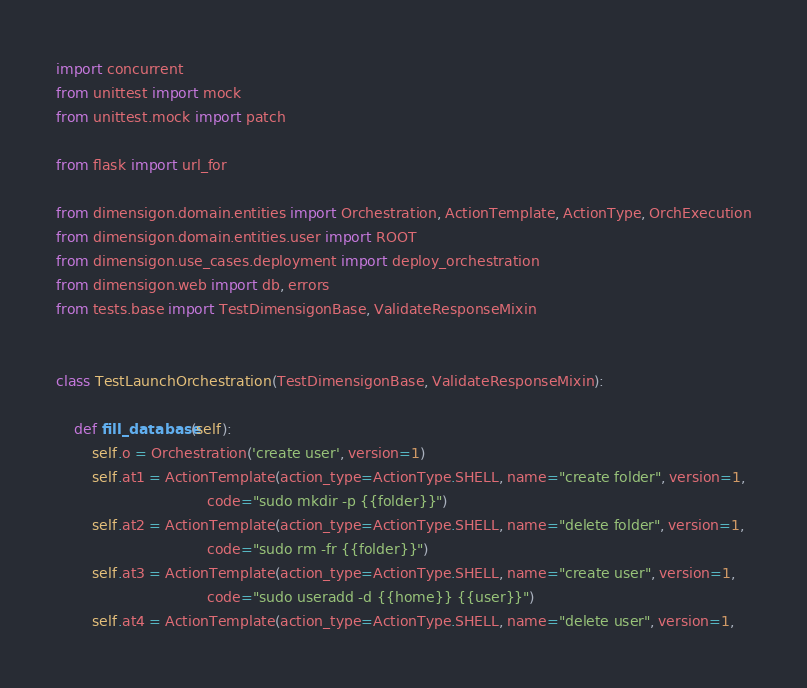<code> <loc_0><loc_0><loc_500><loc_500><_Python_>import concurrent
from unittest import mock
from unittest.mock import patch

from flask import url_for

from dimensigon.domain.entities import Orchestration, ActionTemplate, ActionType, OrchExecution
from dimensigon.domain.entities.user import ROOT
from dimensigon.use_cases.deployment import deploy_orchestration
from dimensigon.web import db, errors
from tests.base import TestDimensigonBase, ValidateResponseMixin


class TestLaunchOrchestration(TestDimensigonBase, ValidateResponseMixin):

    def fill_database(self):
        self.o = Orchestration('create user', version=1)
        self.at1 = ActionTemplate(action_type=ActionType.SHELL, name="create folder", version=1,
                                  code="sudo mkdir -p {{folder}}")
        self.at2 = ActionTemplate(action_type=ActionType.SHELL, name="delete folder", version=1,
                                  code="sudo rm -fr {{folder}}")
        self.at3 = ActionTemplate(action_type=ActionType.SHELL, name="create user", version=1,
                                  code="sudo useradd -d {{home}} {{user}}")
        self.at4 = ActionTemplate(action_type=ActionType.SHELL, name="delete user", version=1,</code> 